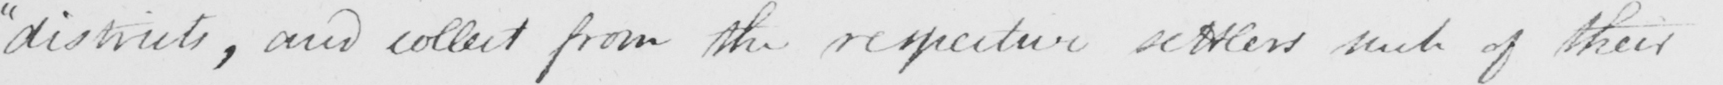What is written in this line of handwriting? " districts , and collect from the respective settlers such of their 